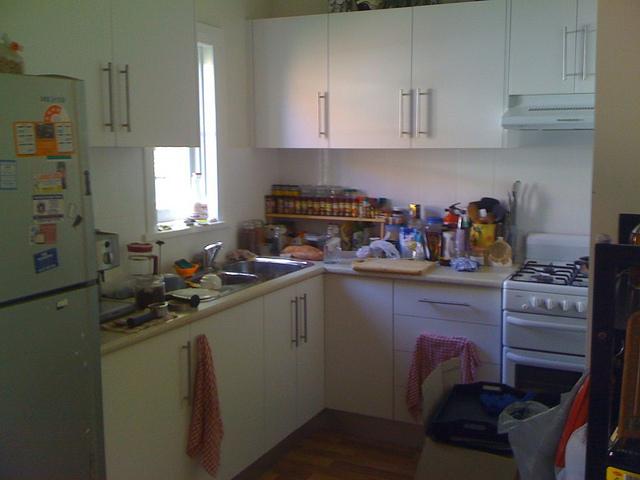What is between the sink and the oven?
Short answer required. Counters. What color are the cabinets?
Keep it brief. White. Could this be in a dorm?
Be succinct. No. Is this likely at someone's house?
Keep it brief. Yes. Is this an industrial kitchen?
Write a very short answer. No. Is the blender empty?
Short answer required. Yes. What are on the freezer door?
Concise answer only. Magnets. Where are the towels hung?
Concise answer only. On handles. Is the person using this kitchen organized?
Keep it brief. No. How many bottles are currently open?
Keep it brief. 0. What is in the basket?
Concise answer only. Clothes. What type of appliance is above the stove?
Be succinct. Fan. Are the walls all one color?
Answer briefly. Yes. What is above the stove?
Give a very brief answer. Cupboard. Is it a full sized kitchen?
Be succinct. Yes. Does this look like a clean working environment?
Concise answer only. No. What are the items lined up in the corner?
Quick response, please. Spices. What brand are the potato chips?
Keep it brief. Lays. 